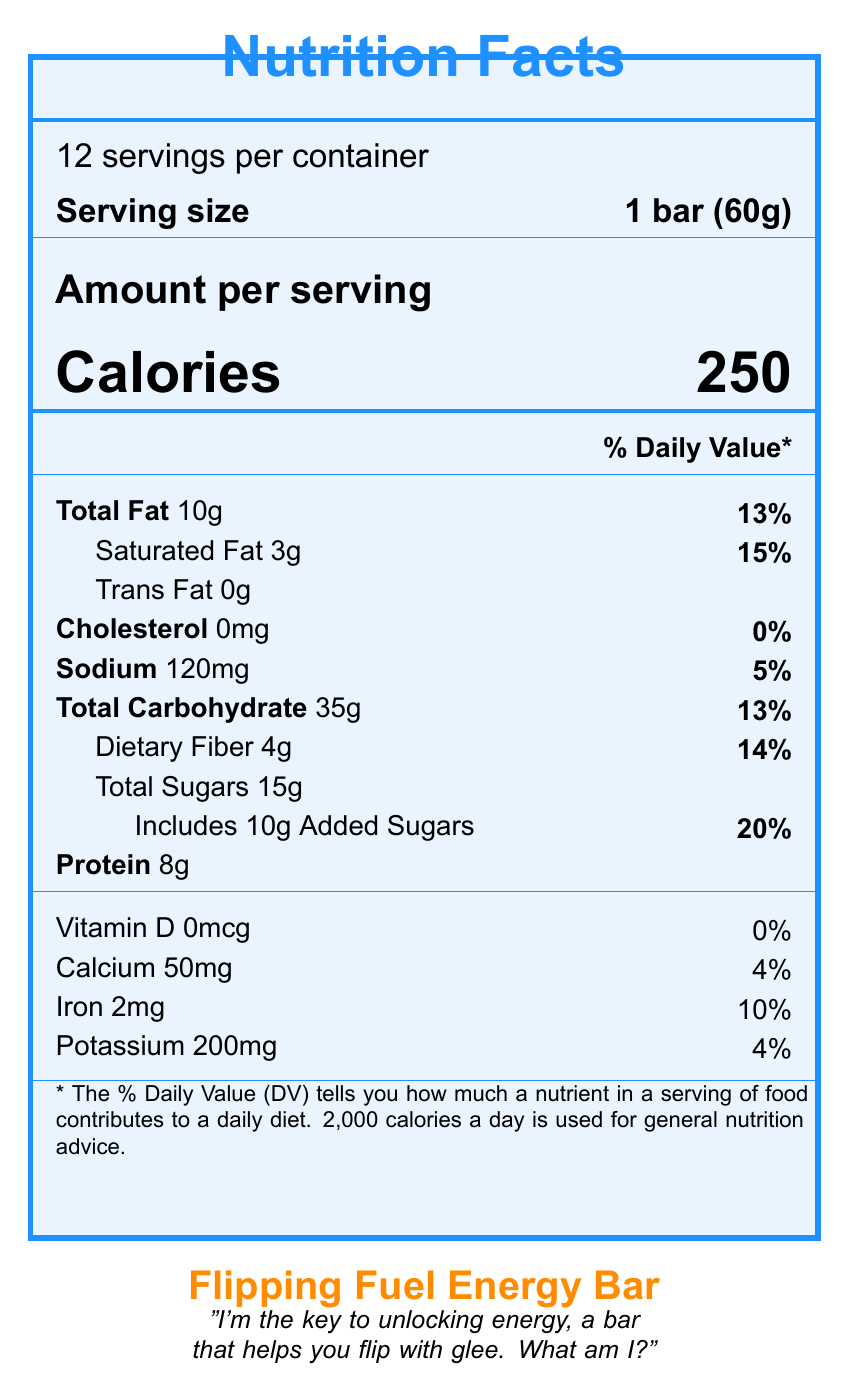what is the total fat content per serving? The document states "Total Fat 10g" under the nutrients section.
Answer: 10g How many servings are in each container? The document mentions "12 servings per container."
Answer: 12 How many grams of protein are in one serving? The document specifies "Protein 8g."
Answer: 8g What is the serving size of the Flipping Fuel Energy Bar? The document indicates that the serving size is "1 bar (60g)."
Answer: 1 bar (60g) what percentage of daily value of fiber does one bar provide? The document shows that dietary fiber in one bar is 4g, which is 14% of the daily value.
Answer: 14% How many calories are in one serving of the energy bar? The document specifies "Calories 250" under the amount per serving section.
Answer: 250 what are the first three ingredients listed? The document lists "Rolled oats, Brown rice syrup, Peanut butter" as the first three ingredients.
Answer: Rolled oats, Brown rice syrup, Peanut butter Which mineral has a higher daily value percentage, iron or potassium? The document specifies that iron has a daily value of 10%, whereas potassium has a daily value of 4%.
Answer: Iron what is the sodium content in one serving? A. 120mg B. 0mg C. 200mg D. 50mg The document states that the sodium content per serving is "120mg."
Answer: A. 120mg How much-added sugars does each energy bar contain? A. 5g B. 10g C. 15g D. 20g The document mentions "Includes 10g Added Sugars."
Answer: B. 10g Does the energy bar contain any cholesterol? The document states "Cholesterol 0mg" with a daily value of 0%.
Answer: No Can this document inform me about the bar's taste? The document does not provide any specific information about the taste of the energy bar.
Answer: Not enough information is the flipping fuel energy bar gluten-free? The document includes the certification "Certified Gluten-Free."
Answer: Yes Summarize the information provided by the document. The explanation covers all the key aspects and data points present in the document and organizes them in a concise manner.
Answer: The document is a detailed nutritional facts label for the Flipping Fuel Energy Bar. It includes serving size, servings per container, caloric content, and the amount of various nutrients per serving along with their daily value percentages. It lists ingredients, potential allergens, storage instructions, the manufacturer, and certifications. There is also a riddle and a competitive banter statement associated with the product. 